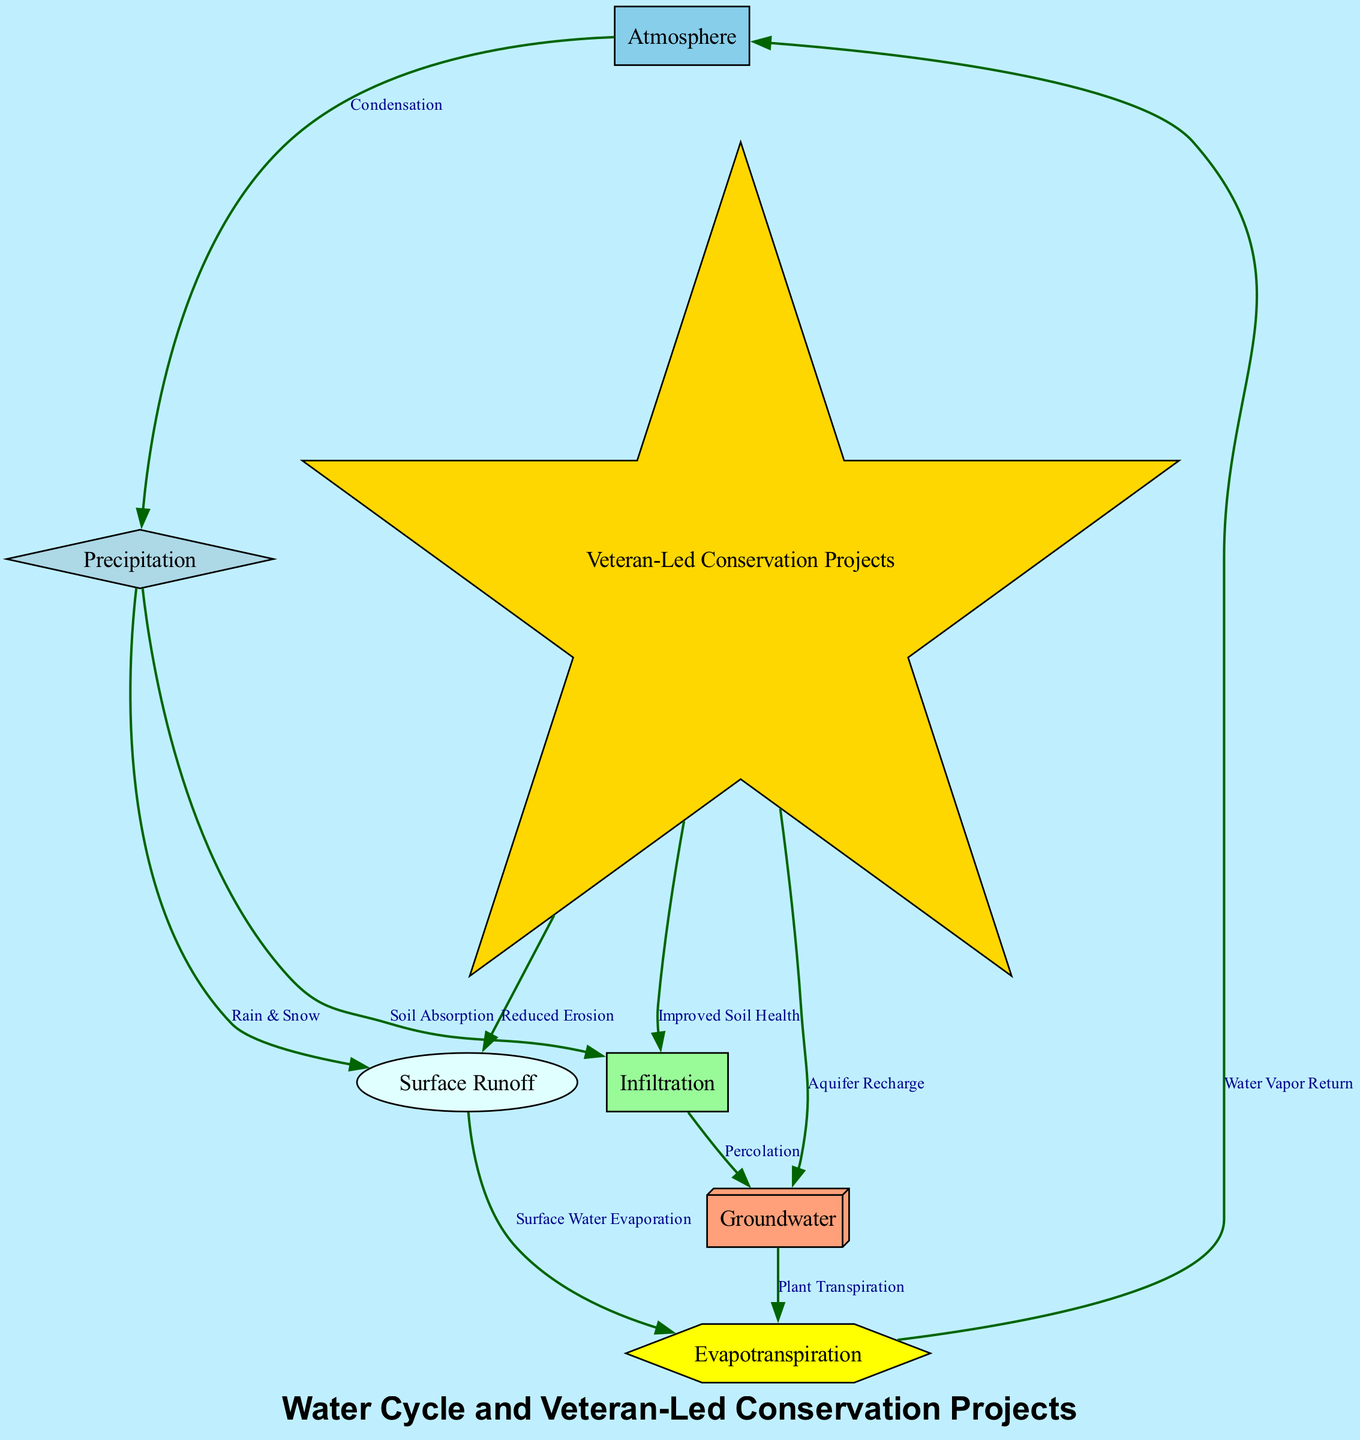What is the total number of nodes in the diagram? The diagram lists seven distinct nodes: Atmosphere, Precipitation, Surface Runoff, Infiltration, Groundwater, Evapotranspiration, and Veteran-Led Conservation Projects. Counting these gives us a total of seven nodes.
Answer: 7 Which process leads from the atmosphere to precipitation? According to the diagram, the transformation from the atmosphere to precipitation is indicated by "Condensation." This relationship shows that condensation is the process by which water vapor in the atmosphere transforms into liquid water, resulting in precipitation.
Answer: Condensation What effects do veteran-led conservation projects have on runoff? The diagram indicates that veteran-led conservation projects relate to runoff through "Reduced Erosion." This means that such conservation efforts help mitigate the erosion of soil, which contributes to decreased runoff.
Answer: Reduced Erosion How does infiltration connect to groundwater? The diagram presents the relationship where infiltration leads to groundwater through the process called "Percolation." This explains that after water infiltrates the soil, it subsequently percolates down through the soil layers to replenish the groundwater.
Answer: Percolation Which node is linked to both surface runoff and groundwater? In the diagram, the node "Evapotranspiration" is connected to both "Surface Runoff" (through surface water evaporation) and "Groundwater" (through plant transpiration), showing how water transitions back to the atmosphere from both runoff and groundwater.
Answer: Evapotranspiration What is the effect of conservation projects on infiltration? The diagram states that veteran-led conservation projects positively influence infiltration through "Improved Soil Health." This indicates that these projects help enhance the quality of the soil, enabling it to absorb water better.
Answer: Improved Soil Health Which process comes after precipitation in the water cycle? The diagram details that after precipitation, the immediate processes that occur are "Surface Runoff" and "Soil Absorption," indicating water's transition from the sky to the ground and its subsequent movement through the water cycle.
Answer: Surface Runoff and Soil Absorption How many connections does the conservation node have? The conservation node has three connections in the diagram: it connects to runoff (Reduced Erosion), infiltration (Improved Soil Health), and groundwater (Aquifer Recharge). Thus, it has three distinct effects on the water cycle.
Answer: 3 What does the water vapor return to the atmosphere signify? The relationship labeled "Water Vapor Return" indicates that the process of evapotranspiration releases water vapor back into the atmosphere. This signifies a crucial part of the water cycle, where water vapor re-enters the atmosphere.
Answer: Water Vapor Return 